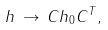Convert formula to latex. <formula><loc_0><loc_0><loc_500><loc_500>h \, \rightarrow \, C h _ { 0 } C ^ { T } ,</formula> 